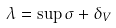<formula> <loc_0><loc_0><loc_500><loc_500>\lambda = \sup \sigma + \delta _ { V }</formula> 